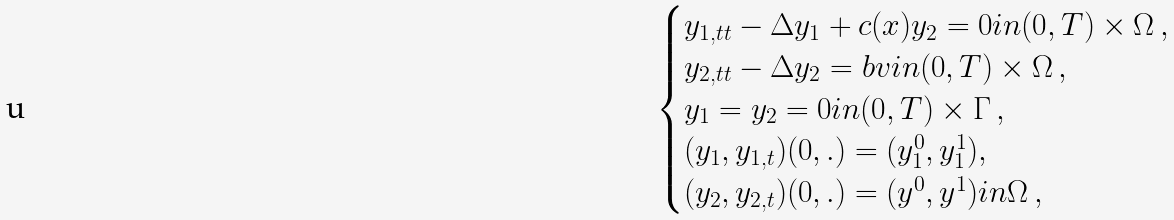Convert formula to latex. <formula><loc_0><loc_0><loc_500><loc_500>\begin{cases} y _ { 1 , t t } - \Delta y _ { 1 } + c ( x ) y _ { 2 } = 0 i n ( 0 , T ) \times \Omega \, , \\ y _ { 2 , t t } - \Delta y _ { 2 } = b v i n ( 0 , T ) \times \Omega \, , \\ y _ { 1 } = y _ { 2 } = 0 i n ( 0 , T ) \times \Gamma \, , \\ ( y _ { 1 } , y _ { 1 , t } ) ( 0 , . ) = ( y _ { 1 } ^ { 0 } , y _ { 1 } ^ { 1 } ) , \\ ( y _ { 2 } , y _ { 2 , t } ) ( 0 , . ) = ( y ^ { 0 } , y ^ { 1 } ) i n \Omega \, , \end{cases}</formula> 